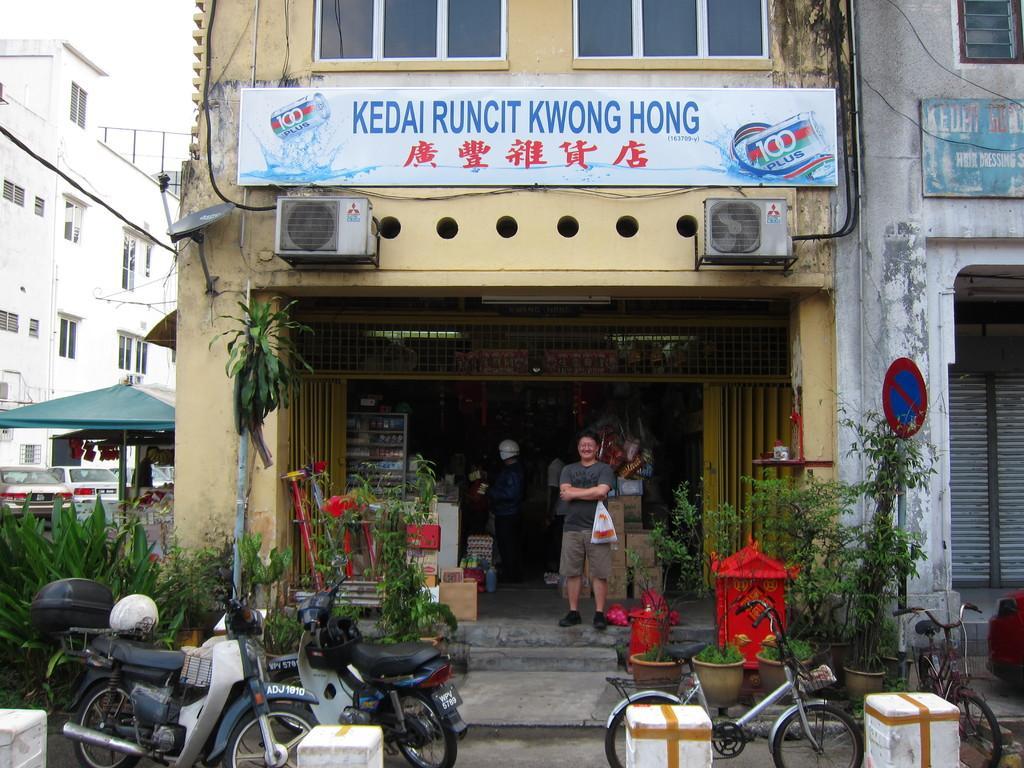Could you give a brief overview of what you see in this image? In the foreground I can see bikes are parked on the road, plants, board and group of people are standing on the floor. In the background I can see buildings, shops, tents and the sky. This image is taken during a day. 